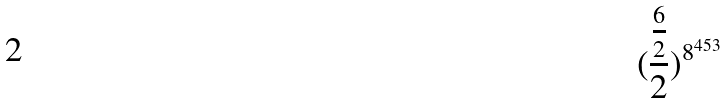<formula> <loc_0><loc_0><loc_500><loc_500>( \frac { \frac { 6 } { 2 } } { 2 } ) ^ { 8 ^ { 4 5 3 } }</formula> 